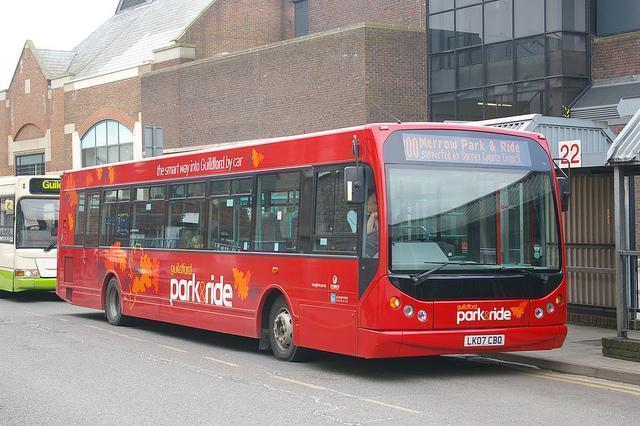What type of transportation is shown?
Make your selection and explain in format: 'Answer: answer
Rationale: rationale.'
Options: Air, rail, road, water. Answer: road.
Rationale: Buses are parked in the street. buses are driven on roads. 